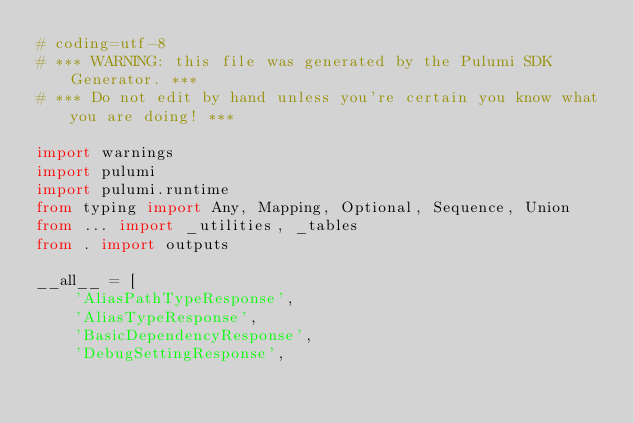Convert code to text. <code><loc_0><loc_0><loc_500><loc_500><_Python_># coding=utf-8
# *** WARNING: this file was generated by the Pulumi SDK Generator. ***
# *** Do not edit by hand unless you're certain you know what you are doing! ***

import warnings
import pulumi
import pulumi.runtime
from typing import Any, Mapping, Optional, Sequence, Union
from ... import _utilities, _tables
from . import outputs

__all__ = [
    'AliasPathTypeResponse',
    'AliasTypeResponse',
    'BasicDependencyResponse',
    'DebugSettingResponse',</code> 